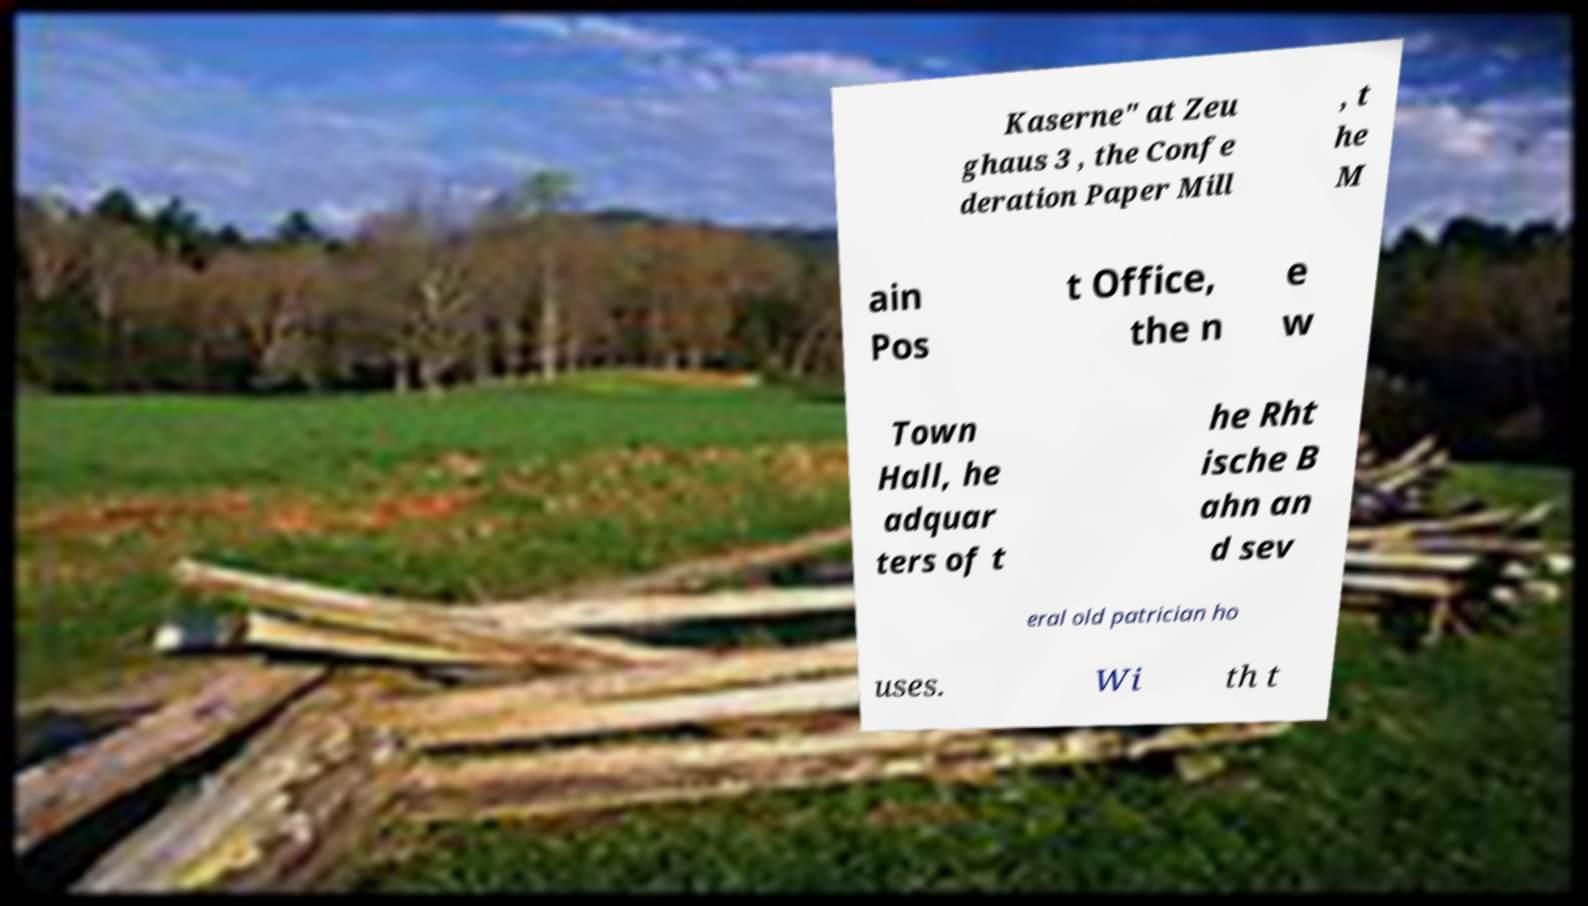What messages or text are displayed in this image? I need them in a readable, typed format. Kaserne" at Zeu ghaus 3 , the Confe deration Paper Mill , t he M ain Pos t Office, the n e w Town Hall, he adquar ters of t he Rht ische B ahn an d sev eral old patrician ho uses. Wi th t 